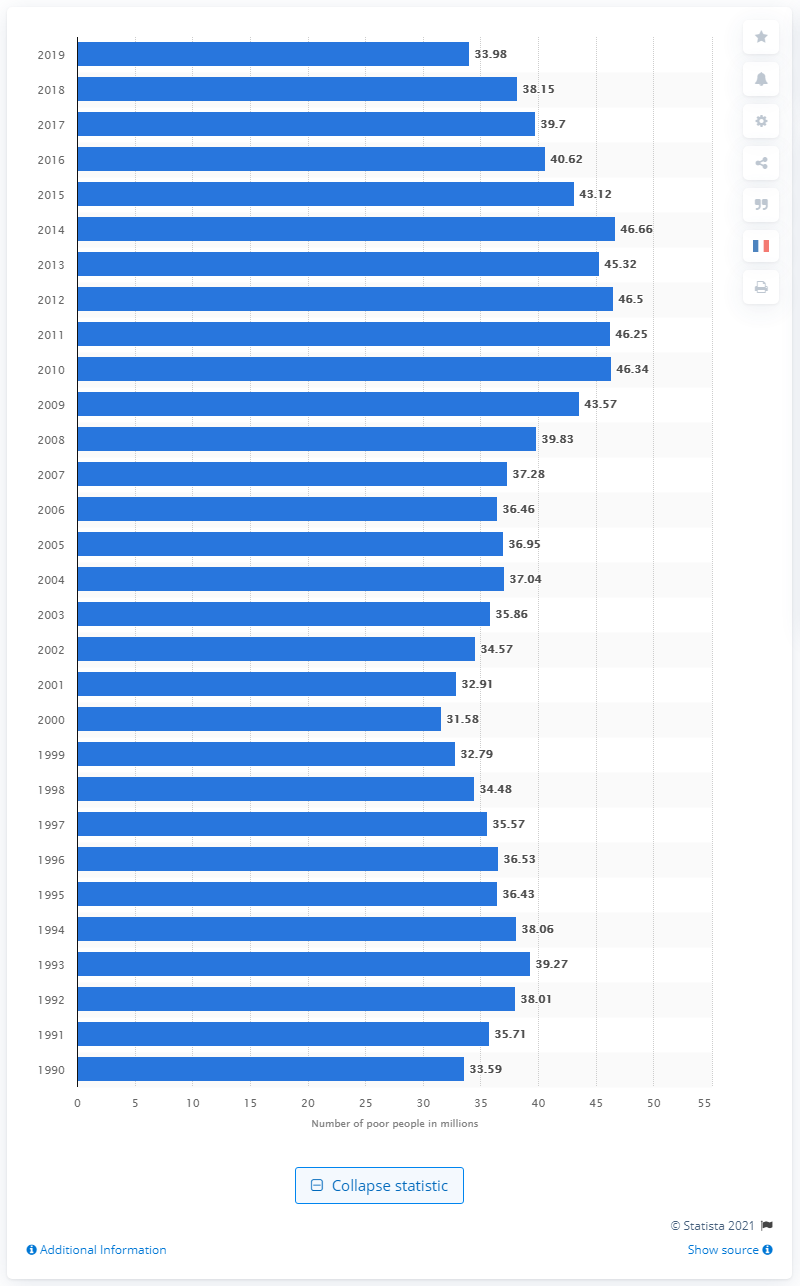Highlight a few significant elements in this photo. In 2019, it is estimated that 33.98% of the population in the United States was living in poverty. 